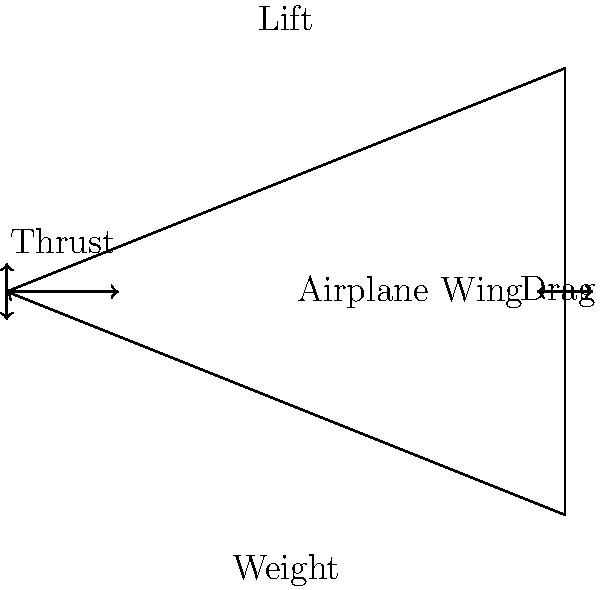During steady, level flight, which force counteracts the weight of the airplane, and how does this force originate? Let's break this down step-by-step:

1. In steady, level flight, four main forces act on an airplane:
   a) Lift (upward)
   b) Weight (downward)
   c) Thrust (forward)
   d) Drag (backward)

2. The force that directly counteracts the weight is the lift force.

3. Lift is generated primarily by the airplane's wings due to the principle of aerodynamics:
   a) The wing's shape (airfoil) causes air to move faster over the top surface than the bottom.
   b) According to Bernoulli's principle, faster-moving air has lower pressure.
   c) This creates a pressure difference between the top and bottom of the wing.

4. The pressure difference results in a net upward force on the wing, which we call lift.

5. For steady, level flight:
   $$ \text{Lift} = \text{Weight} $$

6. The magnitude of lift depends on several factors:
   a) Air density ($\rho$)
   b) Velocity of the aircraft ($v$)
   c) Wing area ($A$)
   d) Lift coefficient ($C_L$)

7. The lift force is calculated using the lift equation:
   $$ L = \frac{1}{2} \rho v^2 A C_L $$

In summary, the lift force, generated by the wing's shape and the resulting pressure difference, counteracts the weight of the airplane during steady, level flight.
Answer: Lift, generated by wing's aerodynamic shape creating pressure difference. 